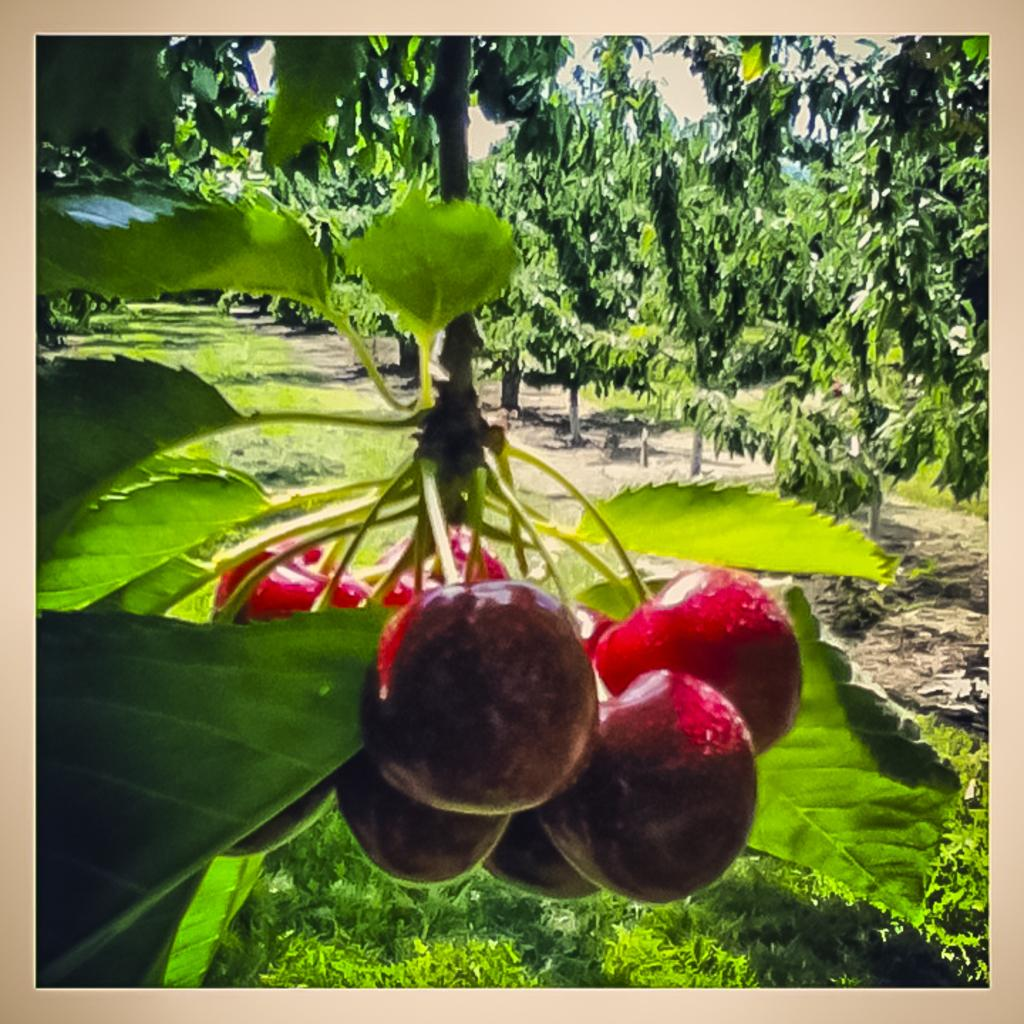What is located in the middle of the image? There are fruits in the middle of the image. What can be seen in the background of the image? There are trees in the background of the image. What type of army is visible in the image? There is no army present in the image; it features fruits and trees. How many attempts can be seen being made in the image? There is no indication of any attempts being made in the image, as it only shows fruits and trees. 